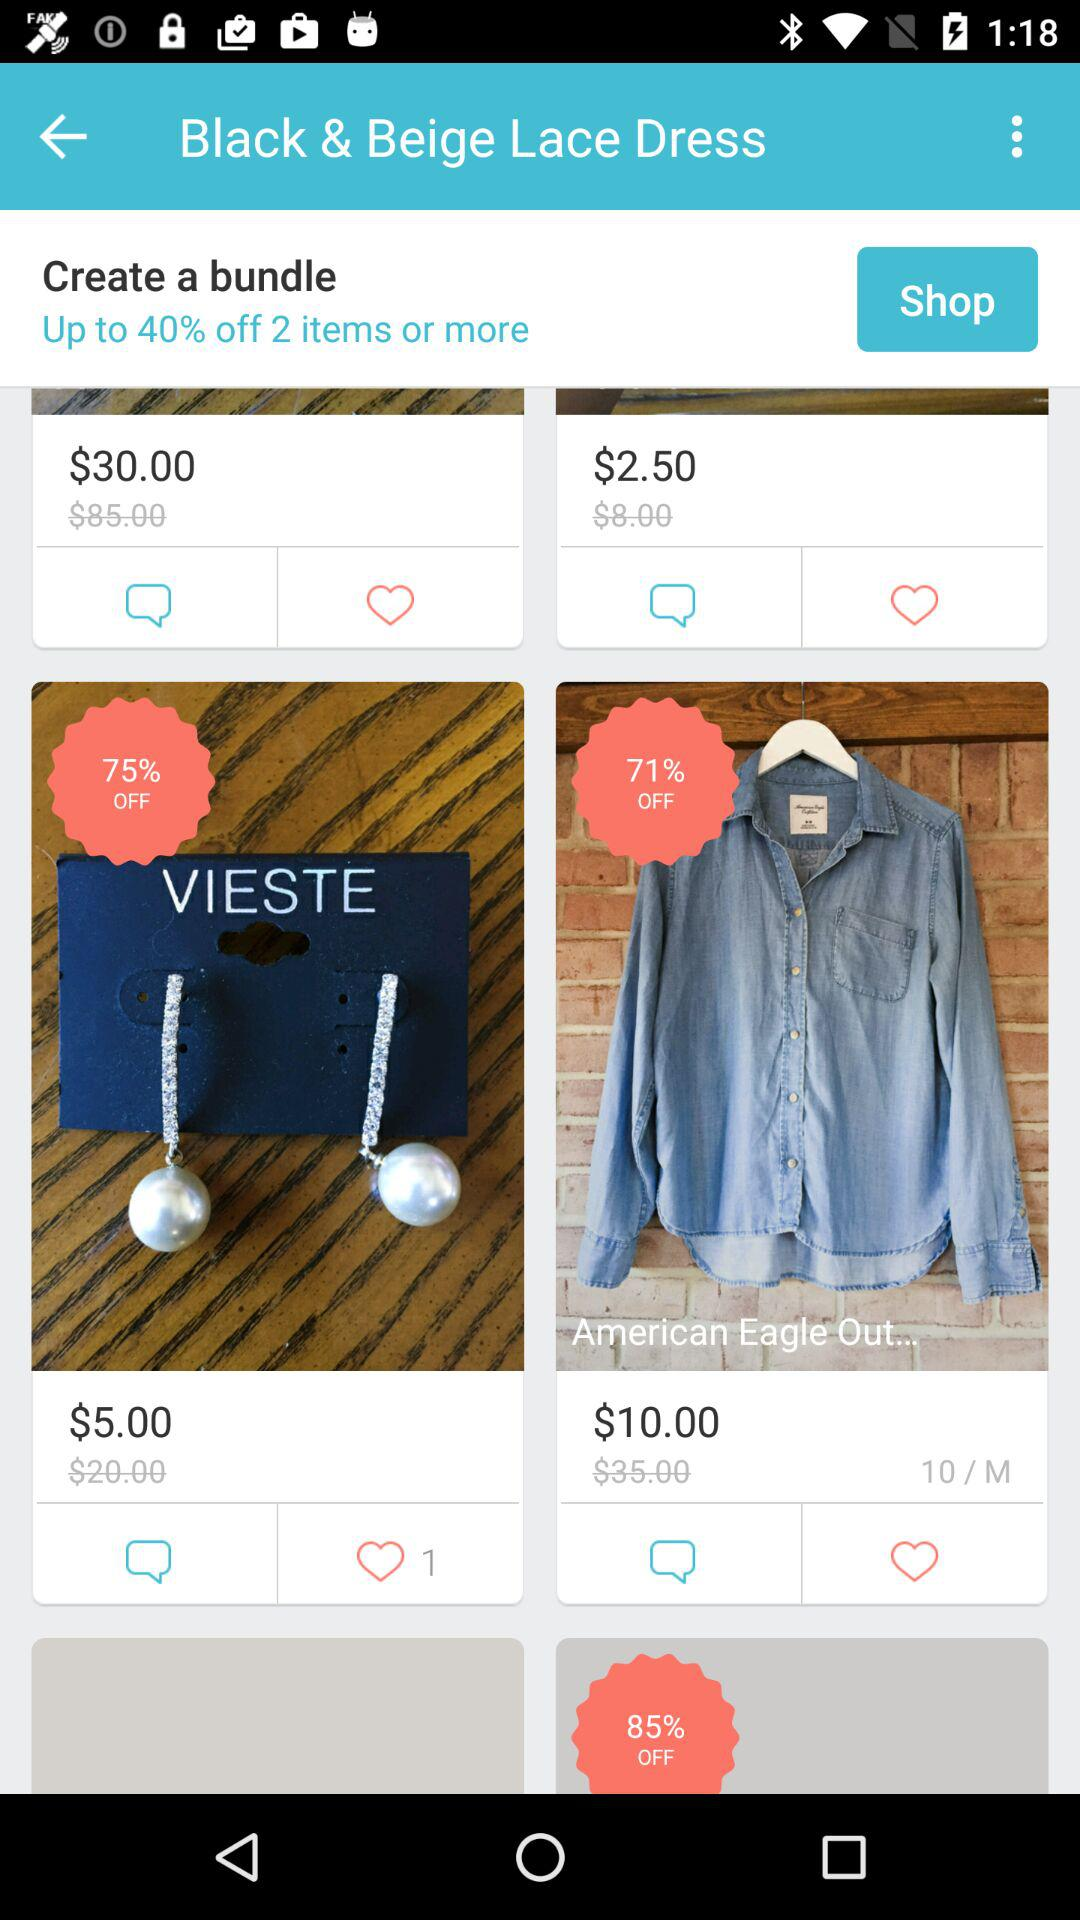What is the given size of "American Eagle Out"? The given size is 10/M. 